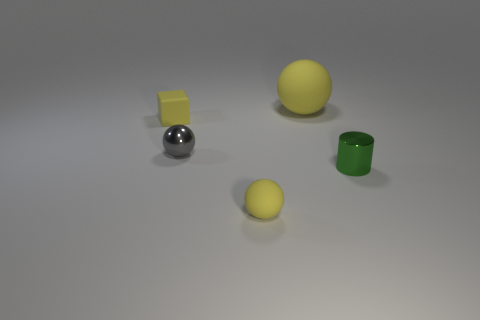There is a matte thing in front of the gray metallic thing; is it the same color as the shiny thing to the right of the gray ball?
Provide a succinct answer. No. How many other objects are the same material as the big thing?
Give a very brief answer. 2. There is a object that is left of the small cylinder and in front of the gray object; what is its shape?
Your answer should be compact. Sphere. There is a block; is its color the same as the tiny matte object that is in front of the green shiny cylinder?
Keep it short and to the point. Yes. There is a matte sphere in front of the cylinder; is it the same size as the tiny green thing?
Your answer should be compact. Yes. There is a big yellow object that is the same shape as the tiny gray metallic object; what is it made of?
Your answer should be compact. Rubber. Is the shape of the green thing the same as the large yellow matte object?
Provide a succinct answer. No. There is a big yellow rubber ball that is behind the tiny gray sphere; what number of things are in front of it?
Keep it short and to the point. 4. The tiny thing that is made of the same material as the cylinder is what shape?
Provide a succinct answer. Sphere. What number of brown objects are tiny shiny spheres or shiny objects?
Offer a very short reply. 0. 